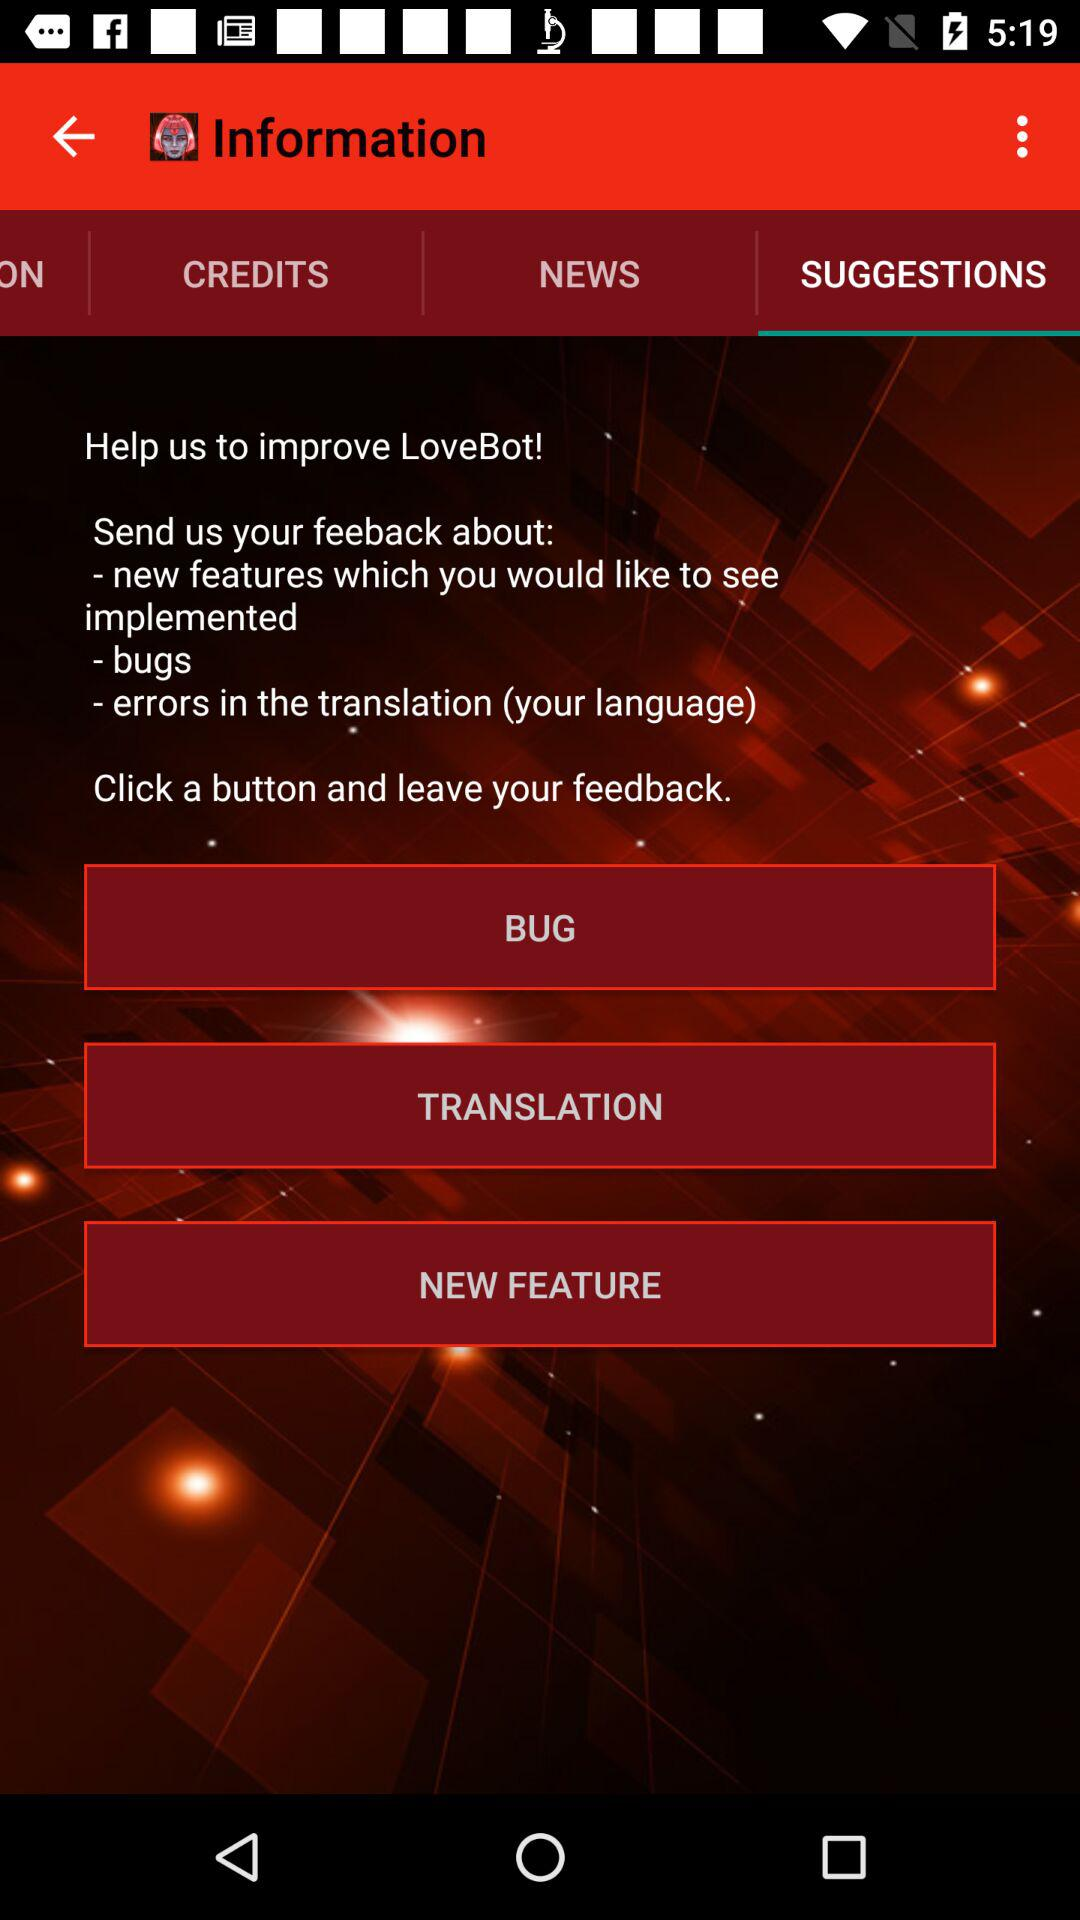Which tab is selected? The selected tab is "SUGGESTIONS". 